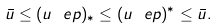<formula> <loc_0><loc_0><loc_500><loc_500>\bar { u } \leq ( u ^ { \ } e p ) _ { * } \leq ( u ^ { \ } e p ) ^ { * } \leq \bar { u } .</formula> 